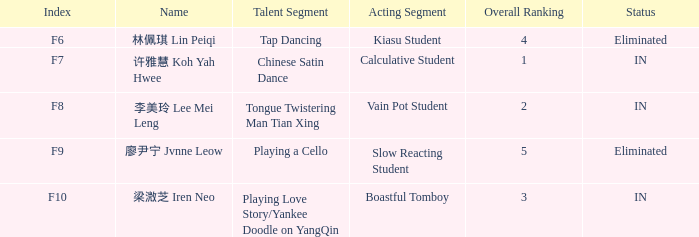For the event with index f7, what is the status? IN. 